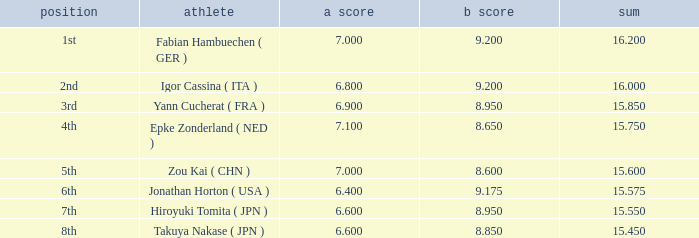What was the total rating that had a score higher than 7 and a b score smaller than 8.65? None. 